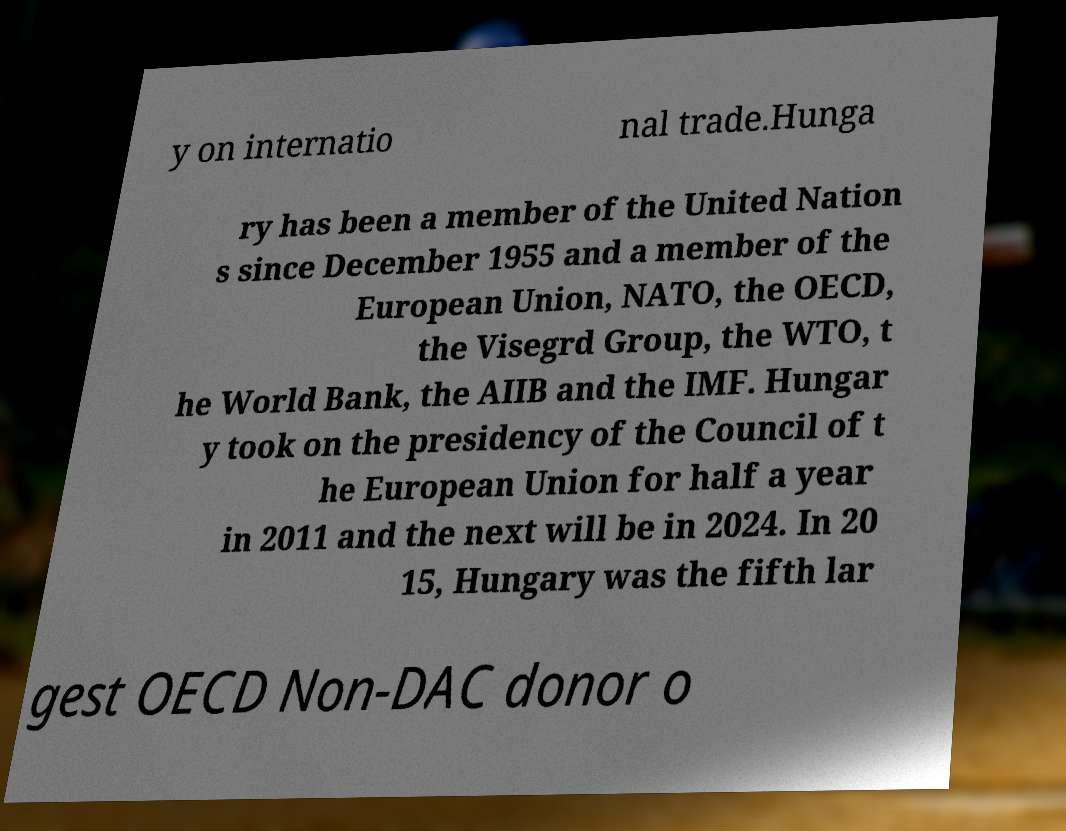Please read and relay the text visible in this image. What does it say? y on internatio nal trade.Hunga ry has been a member of the United Nation s since December 1955 and a member of the European Union, NATO, the OECD, the Visegrd Group, the WTO, t he World Bank, the AIIB and the IMF. Hungar y took on the presidency of the Council of t he European Union for half a year in 2011 and the next will be in 2024. In 20 15, Hungary was the fifth lar gest OECD Non-DAC donor o 